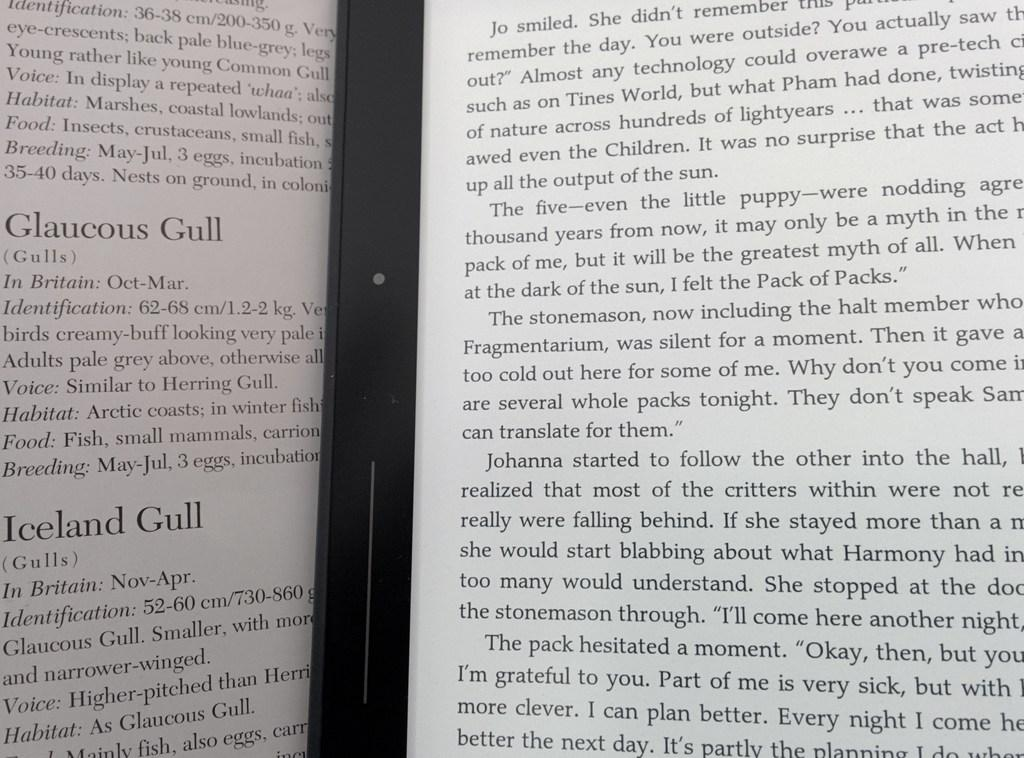<image>
Render a clear and concise summary of the photo. A book about birds lies open to a page about Glaucous Gulls 